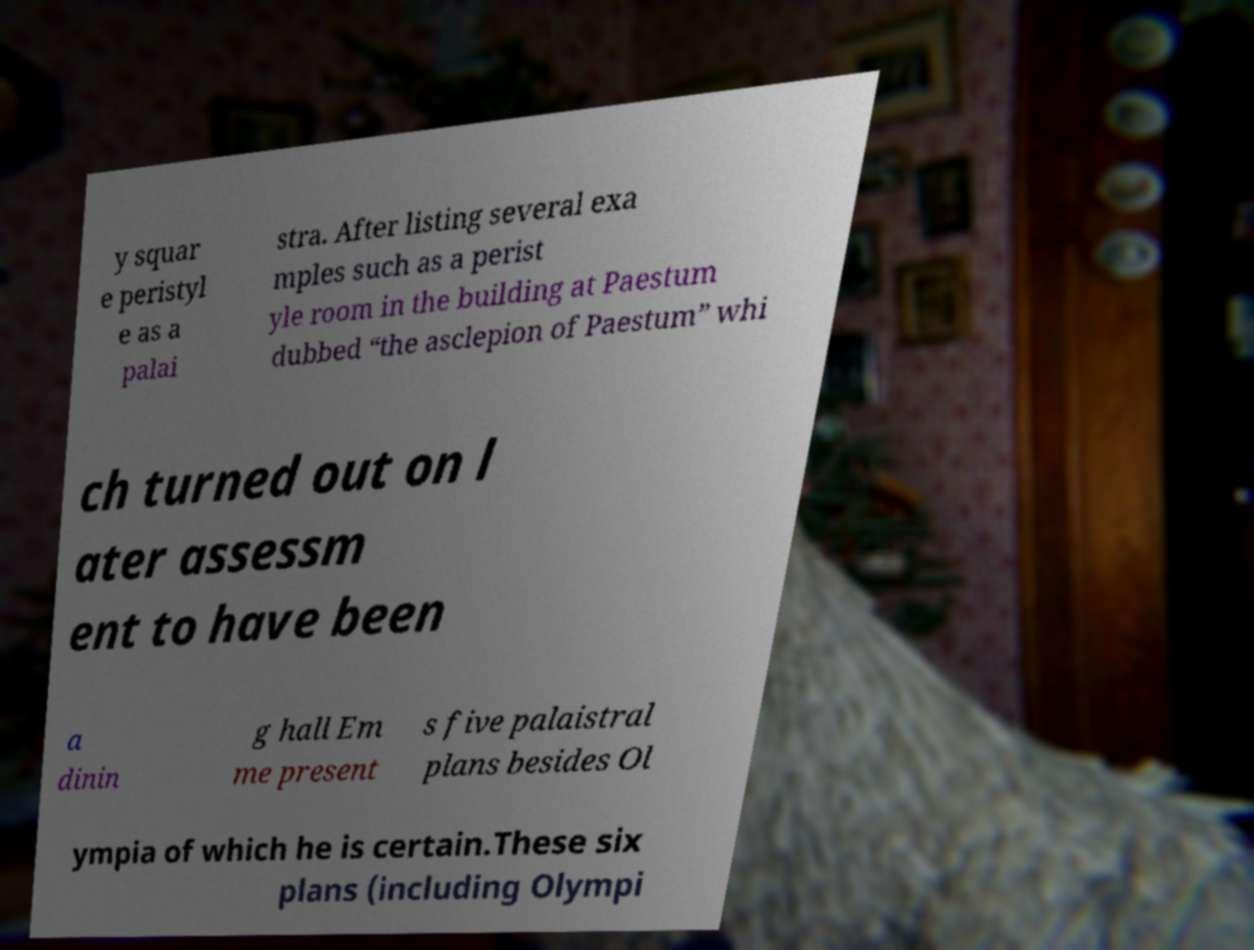For documentation purposes, I need the text within this image transcribed. Could you provide that? y squar e peristyl e as a palai stra. After listing several exa mples such as a perist yle room in the building at Paestum dubbed “the asclepion of Paestum” whi ch turned out on l ater assessm ent to have been a dinin g hall Em me present s five palaistral plans besides Ol ympia of which he is certain.These six plans (including Olympi 